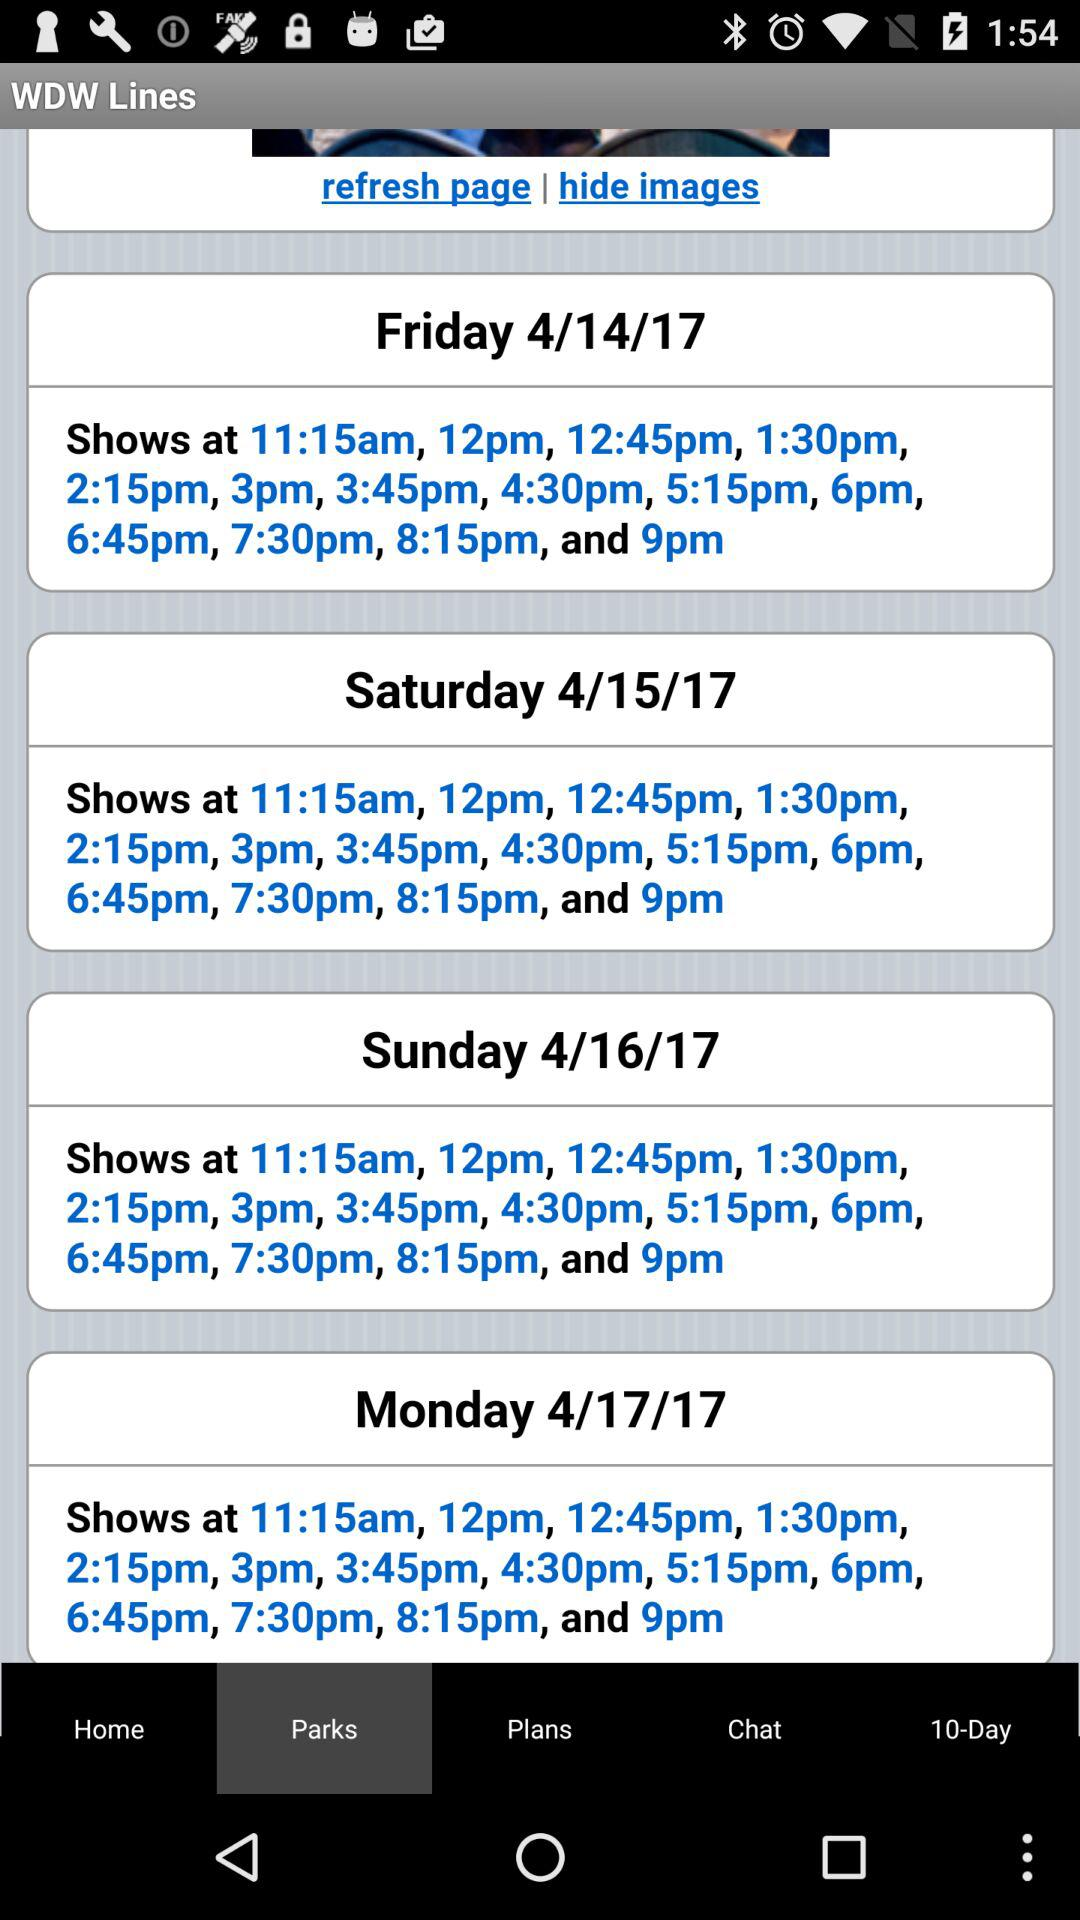What is the show time for Saturday? The show times for Saturday are 11:15 a.m., 12 p.m., 12:45 p.m., 1:30 p.m., 2:15 p.m., 3 p.m., 3:45 p.m., 4:30 p.m., 5:15 p.m., 6 p.m., 6:45 p.m., 7:30 p.m., 8:15 p.m. and 9 p.m. 